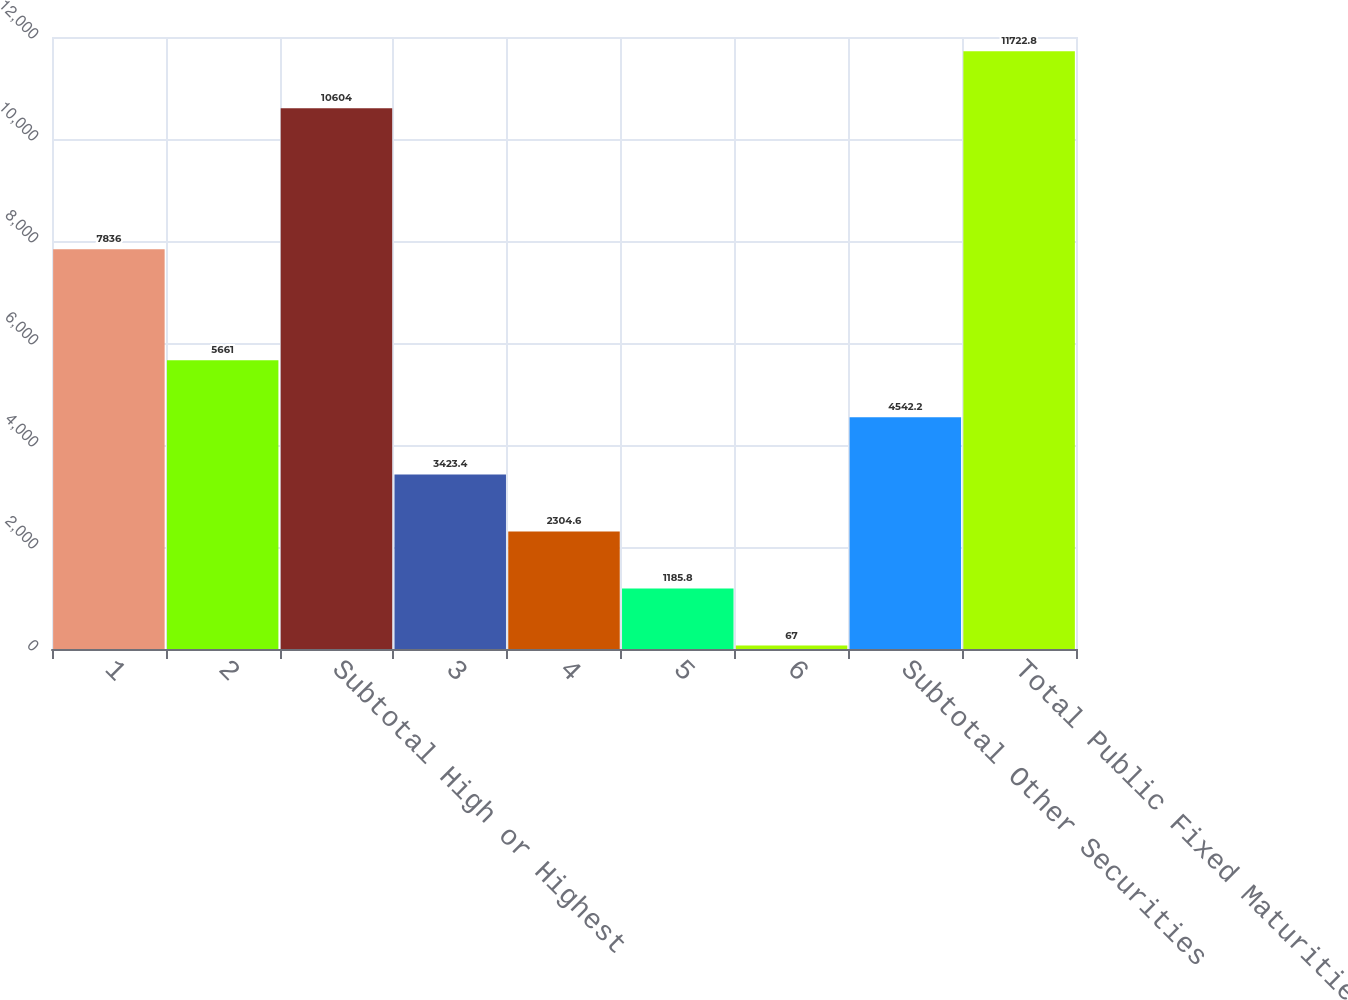Convert chart. <chart><loc_0><loc_0><loc_500><loc_500><bar_chart><fcel>1<fcel>2<fcel>Subtotal High or Highest<fcel>3<fcel>4<fcel>5<fcel>6<fcel>Subtotal Other Securities<fcel>Total Public Fixed Maturities<nl><fcel>7836<fcel>5661<fcel>10604<fcel>3423.4<fcel>2304.6<fcel>1185.8<fcel>67<fcel>4542.2<fcel>11722.8<nl></chart> 